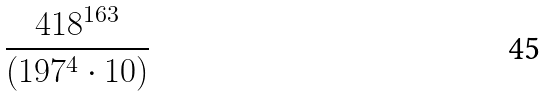Convert formula to latex. <formula><loc_0><loc_0><loc_500><loc_500>\frac { 4 1 8 ^ { 1 6 3 } } { ( 1 9 7 ^ { 4 } \cdot 1 0 ) }</formula> 